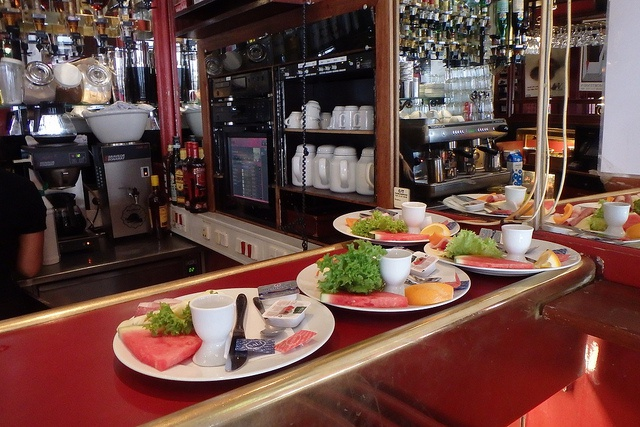Describe the objects in this image and their specific colors. I can see cup in gray, darkgray, lightgray, and black tones, people in maroon, black, and gray tones, tv in gray, black, and purple tones, cup in gray, lightgray, darkgray, and tan tones, and bowl in gray tones in this image. 